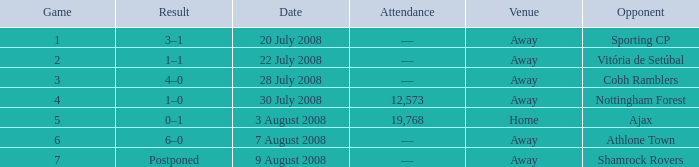What is the venue of game 3? Away. 